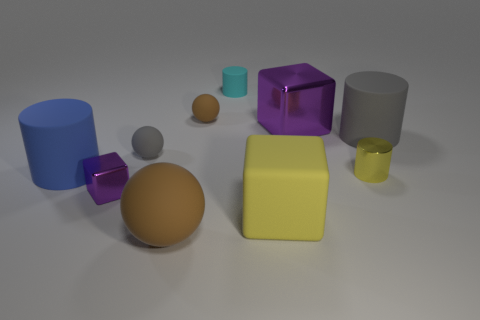What is the material of the small ball that is the same color as the large matte ball?
Offer a very short reply. Rubber. What material is the tiny cyan thing that is the same shape as the blue matte object?
Offer a terse response. Rubber. What is the color of the metal block that is in front of the large cylinder that is in front of the small gray matte sphere?
Make the answer very short. Purple. The object that is the same color as the rubber cube is what size?
Offer a very short reply. Small. There is a metal block that is on the left side of the brown rubber sphere in front of the yellow cylinder; what number of gray cylinders are in front of it?
Make the answer very short. 0. There is a brown rubber object that is behind the gray sphere; is it the same shape as the purple shiny thing in front of the blue matte object?
Offer a very short reply. No. How many things are tiny brown metallic cubes or tiny cyan cylinders?
Provide a short and direct response. 1. What material is the large cylinder on the right side of the big yellow rubber block that is in front of the gray matte cylinder?
Your response must be concise. Rubber. Is there a matte cube of the same color as the large sphere?
Ensure brevity in your answer.  No. There is another cube that is the same size as the yellow matte cube; what is its color?
Give a very brief answer. Purple. 